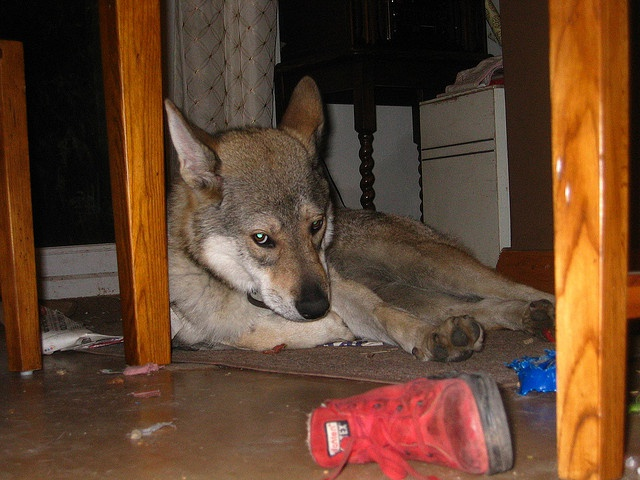Describe the objects in this image and their specific colors. I can see dog in black, gray, and maroon tones, chair in black, brown, and orange tones, and chair in black, maroon, and brown tones in this image. 